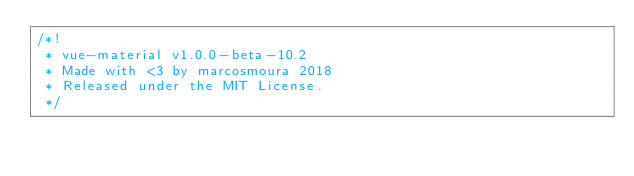<code> <loc_0><loc_0><loc_500><loc_500><_CSS_>/*!
 * vue-material v1.0.0-beta-10.2
 * Made with <3 by marcosmoura 2018
 * Released under the MIT License.
 */</code> 